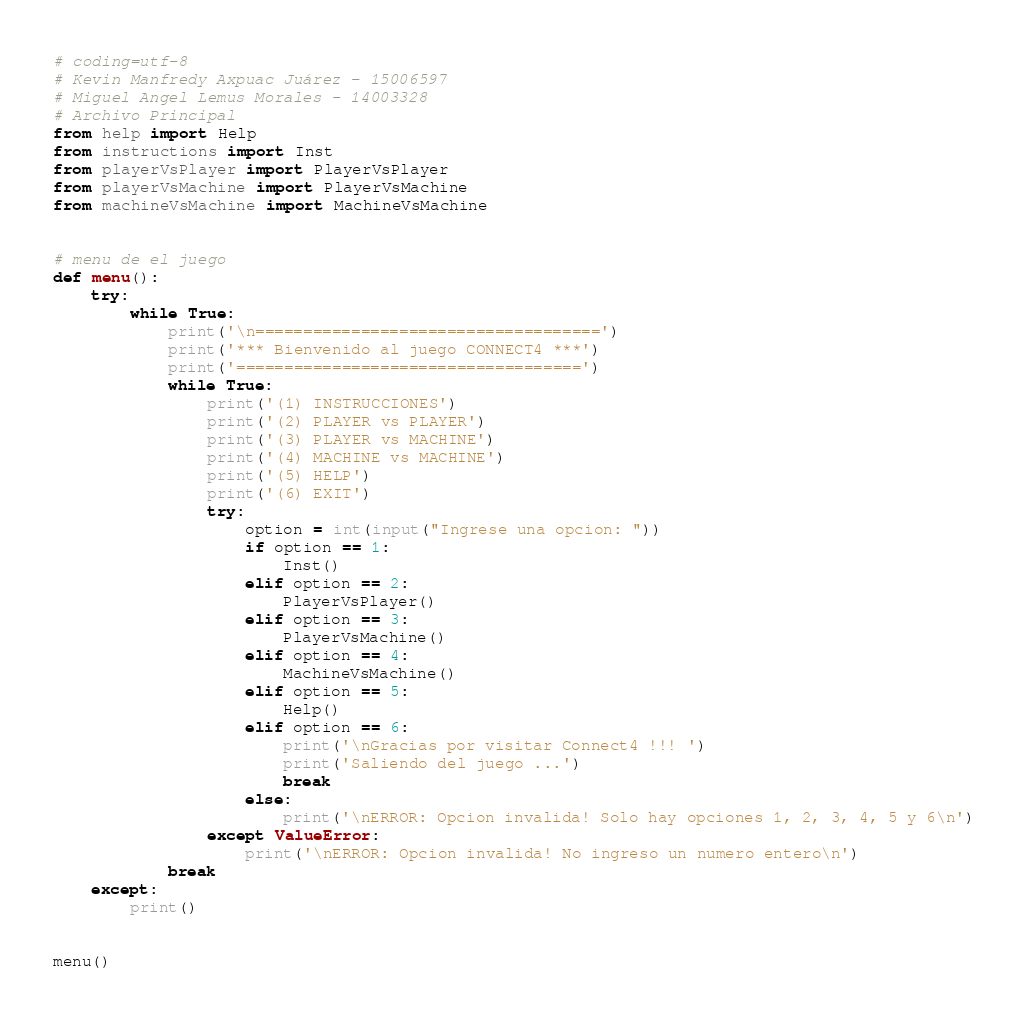<code> <loc_0><loc_0><loc_500><loc_500><_Python_># coding=utf-8
# Kevin Manfredy Axpuac Juárez - 15006597
# Miguel Angel Lemus Morales - 14003328
# Archivo Principal
from help import Help
from instructions import Inst
from playerVsPlayer import PlayerVsPlayer
from playerVsMachine import PlayerVsMachine
from machineVsMachine import MachineVsMachine


# menu de el juego
def menu():
    try:
        while True:
            print('\n====================================')
            print('*** Bienvenido al juego CONNECT4 ***')
            print('====================================')
            while True:
                print('(1) INSTRUCCIONES')
                print('(2) PLAYER vs PLAYER')
                print('(3) PLAYER vs MACHINE')
                print('(4) MACHINE vs MACHINE')
                print('(5) HELP')
                print('(6) EXIT')
                try:
                    option = int(input("Ingrese una opcion: "))
                    if option == 1:
                        Inst()
                    elif option == 2:
                        PlayerVsPlayer()
                    elif option == 3:
                        PlayerVsMachine()
                    elif option == 4:
                        MachineVsMachine()
                    elif option == 5:
                        Help()
                    elif option == 6:
                        print('\nGracias por visitar Connect4 !!! ')
                        print('Saliendo del juego ...')
                        break
                    else:
                        print('\nERROR: Opcion invalida! Solo hay opciones 1, 2, 3, 4, 5 y 6\n')
                except ValueError:
                    print('\nERROR: Opcion invalida! No ingreso un numero entero\n')
            break
    except:
        print()


menu()
</code> 